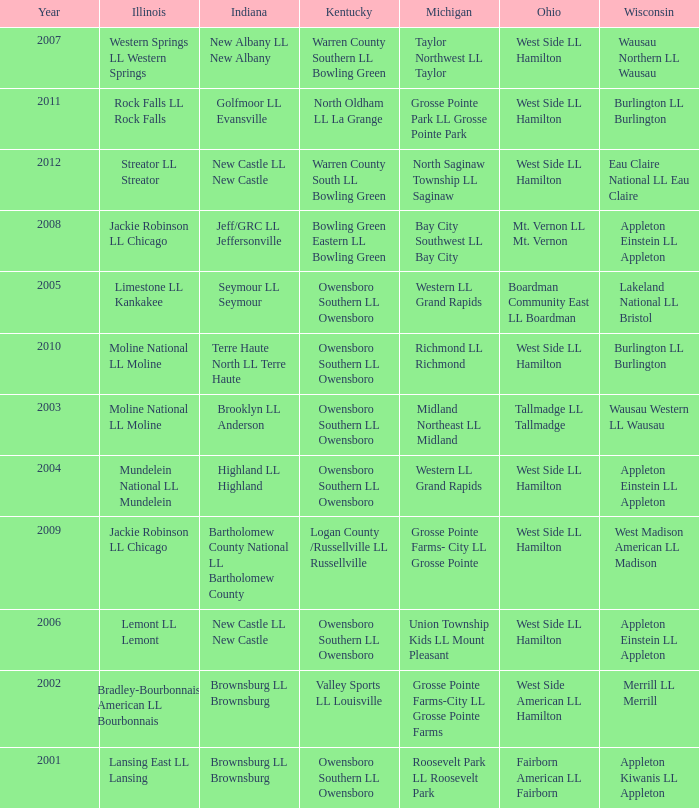What was the little league team from Kentucky when the little league team from Michigan was Grosse Pointe Farms-City LL Grosse Pointe Farms?  Valley Sports LL Louisville. 